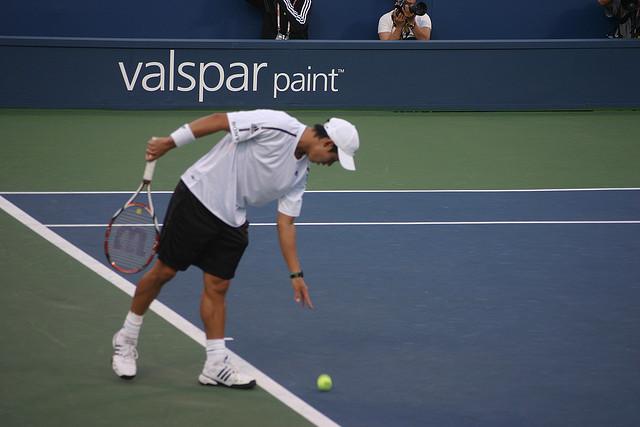What is the sport?
Keep it brief. Tennis. What is the role of the rightmost person in the picture?
Answer briefly. Photographer. What color is the ball?
Concise answer only. Yellow. Where is the tennis ball?
Concise answer only. Ground. What is the man in the background doing?
Be succinct. Photographing. What kind of hat is this person wearing?
Be succinct. Baseball cap. How many tennis players are on the tennis court?
Quick response, please. 1. 